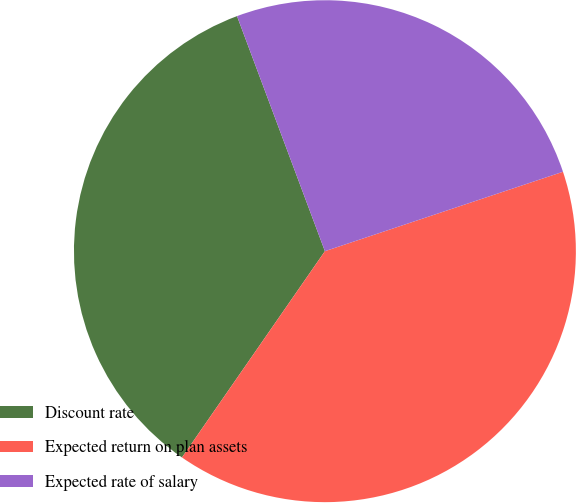Convert chart. <chart><loc_0><loc_0><loc_500><loc_500><pie_chart><fcel>Discount rate<fcel>Expected return on plan assets<fcel>Expected rate of salary<nl><fcel>34.66%<fcel>39.77%<fcel>25.57%<nl></chart> 